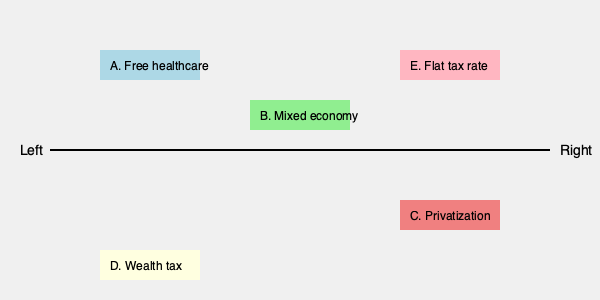Match the economic policies (A-E) to their most likely positions on the left-right political spectrum. Which policy would be placed furthest to the right? To answer this question, we need to understand the general principles of left-right economic policies:

1. Left-wing economic policies typically favor:
   - Greater government intervention in the economy
   - Wealth redistribution
   - Public ownership of key industries
   - Progressive taxation

2. Right-wing economic policies typically favor:
   - Less government intervention
   - Free-market capitalism
   - Private ownership
   - Lower taxes, especially for businesses and high-income individuals

Now, let's analyze each policy:

A. Free healthcare: This is a left-wing policy as it involves significant government intervention and public funding.

B. Mixed economy: This falls somewhere in the center, as it combines elements of both free-market capitalism and government intervention.

C. Privatization: This is a right-wing policy that involves transferring public services or assets to private ownership.

D. Wealth tax: This is a left-wing policy aimed at redistributing wealth from the richest members of society.

E. Flat tax rate: This is a right-wing policy that typically benefits higher-income individuals more than progressive tax systems.

Among these policies, privatization (C) and flat tax rate (E) are the most right-wing. However, privatization is generally considered further to the right as it more directly reduces government involvement in the economy.
Answer: C. Privatization 